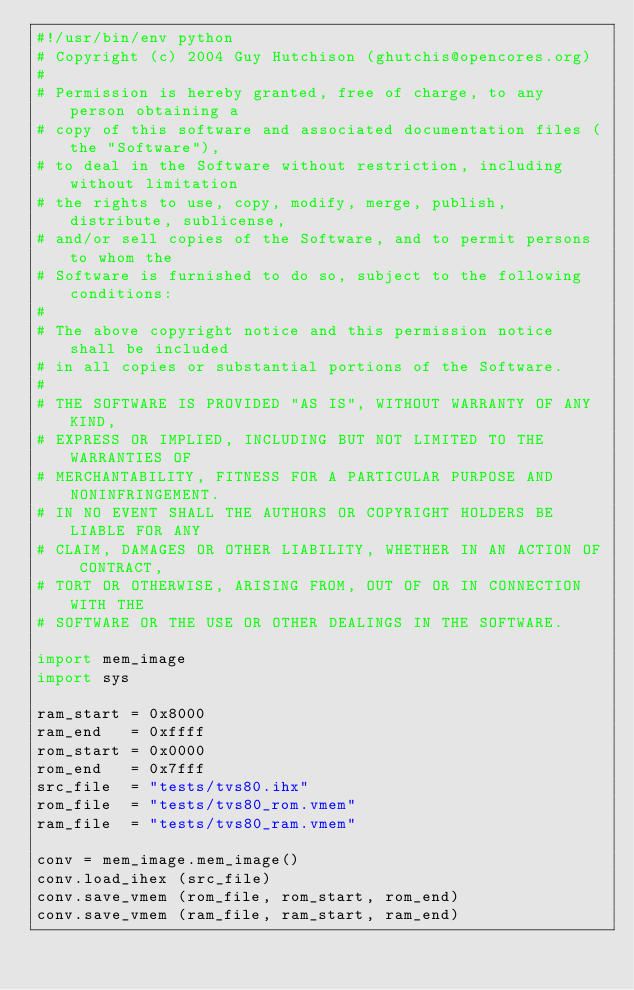<code> <loc_0><loc_0><loc_500><loc_500><_Python_>#!/usr/bin/env python
# Copyright (c) 2004 Guy Hutchison (ghutchis@opencores.org)
#
# Permission is hereby granted, free of charge, to any person obtaining a
# copy of this software and associated documentation files (the "Software"),
# to deal in the Software without restriction, including without limitation
# the rights to use, copy, modify, merge, publish, distribute, sublicense,
# and/or sell copies of the Software, and to permit persons to whom the
# Software is furnished to do so, subject to the following conditions:
#
# The above copyright notice and this permission notice shall be included
# in all copies or substantial portions of the Software.
#
# THE SOFTWARE IS PROVIDED "AS IS", WITHOUT WARRANTY OF ANY KIND,
# EXPRESS OR IMPLIED, INCLUDING BUT NOT LIMITED TO THE WARRANTIES OF
# MERCHANTABILITY, FITNESS FOR A PARTICULAR PURPOSE AND NONINFRINGEMENT.
# IN NO EVENT SHALL THE AUTHORS OR COPYRIGHT HOLDERS BE LIABLE FOR ANY
# CLAIM, DAMAGES OR OTHER LIABILITY, WHETHER IN AN ACTION OF CONTRACT,
# TORT OR OTHERWISE, ARISING FROM, OUT OF OR IN CONNECTION WITH THE
# SOFTWARE OR THE USE OR OTHER DEALINGS IN THE SOFTWARE.

import mem_image
import sys

ram_start = 0x8000
ram_end   = 0xffff
rom_start = 0x0000
rom_end   = 0x7fff
src_file  = "tests/tvs80.ihx"
rom_file  = "tests/tvs80_rom.vmem"
ram_file  = "tests/tvs80_ram.vmem"

conv = mem_image.mem_image()
conv.load_ihex (src_file)
conv.save_vmem (rom_file, rom_start, rom_end)
conv.save_vmem (ram_file, ram_start, ram_end)
</code> 